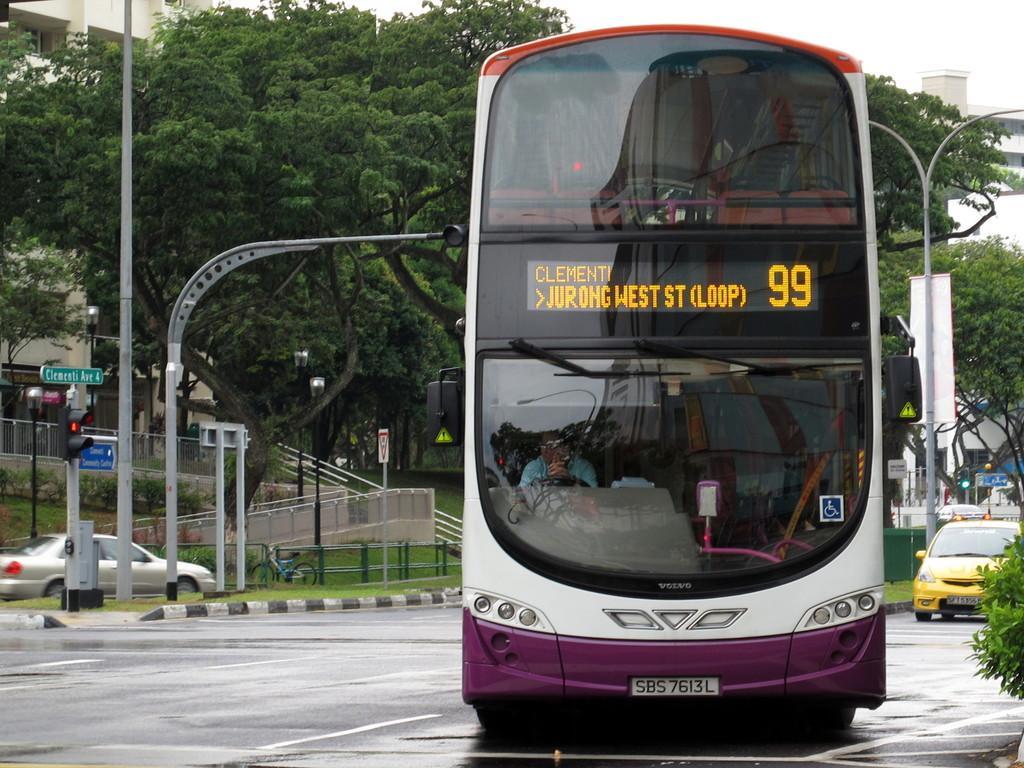Could you give a brief overview of what you see in this image? In this image there is a double decker bus on the road, behind that there are some cars, electric poles, trees and buildings. 